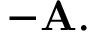Convert formula to latex. <formula><loc_0><loc_0><loc_500><loc_500>- A .</formula> 